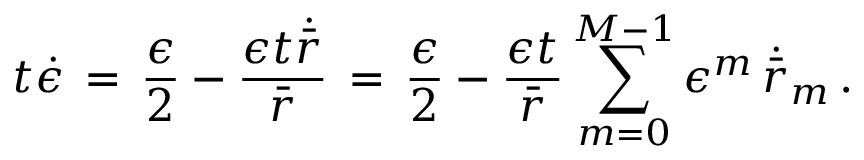Convert formula to latex. <formula><loc_0><loc_0><loc_500><loc_500>t \dot { \epsilon } \, = \, \frac { \epsilon } { 2 } - \frac { \epsilon t \dot { \bar { r } } } { \bar { r } } \, = \, \frac { \epsilon } { 2 } - \frac { \epsilon t } { \bar { r } } \sum _ { m = 0 } ^ { M - 1 } \epsilon ^ { m } \, \dot { \bar { r } } _ { m } \, .</formula> 